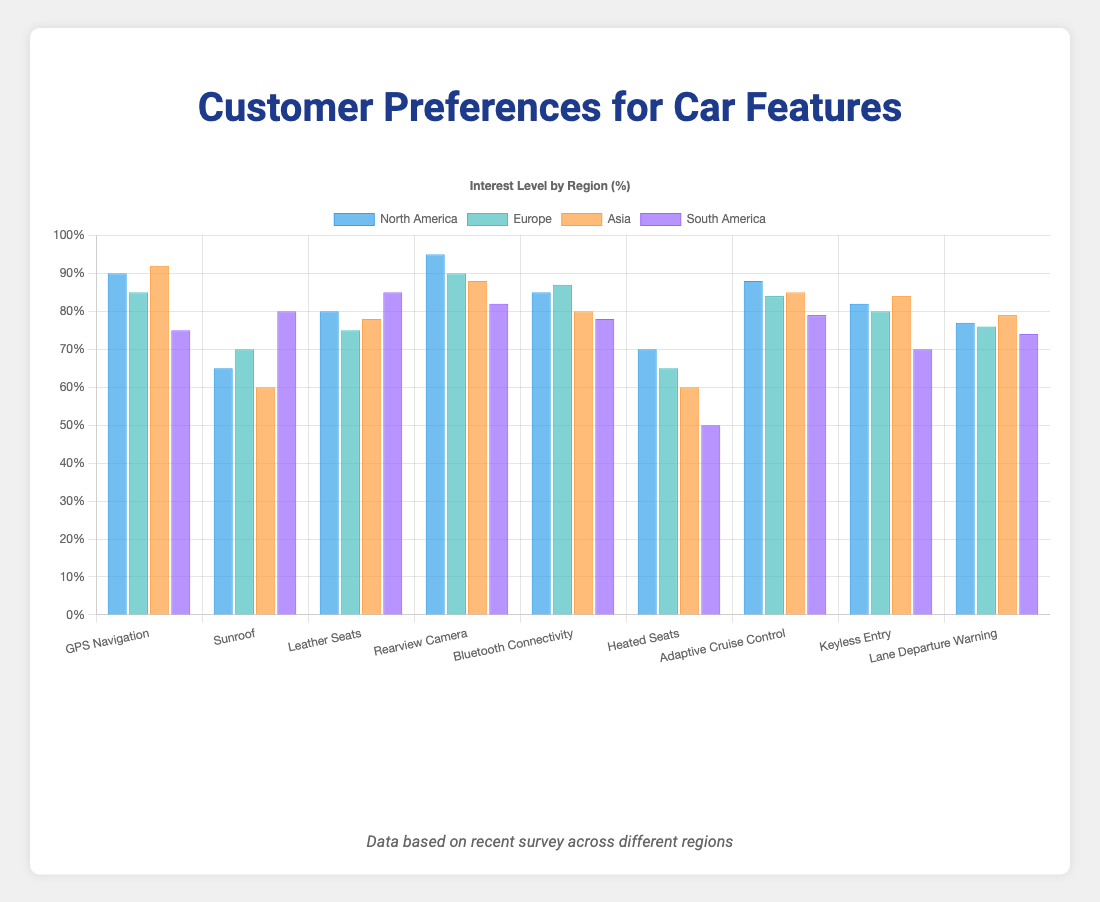What feature has the highest interest level in North America? Look at the bar heights in the "North America" dataset; the tallest bar represents the feature with the highest interest level. "Rearview Camera" with 95% is the highest.
Answer: Rearview Camera Which region shows the least interest in Heated Seats? Compare the bar heights for "Heated Seats" across all regions. The shortest bar for Heated Seats is in South America at 50%.
Answer: South America What's the average interest level in Bluetooth Connectivity across all regions? Sum the interest levels for Bluetooth Connectivity in each region (85 + 87 + 80 + 78) and then divide by the number of regions (4). The calculation is (330 / 4) = 82.5%.
Answer: 82.5% Which feature has almost the same interest level in Europe and Asia? Look for features where the bar heights for Europe and Asia are close to each other. "Adaptive Cruise Control" has 84% for Europe and 85% for Asia.
Answer: Adaptive Cruise Control How does the interest level in Keyless Entry in North America compare to South America? Compare the bar heights for "Keyless Entry" in the North America and South America datasets. North America has 82% and South America has 70%; North America's interest is higher.
Answer: North America has a higher interest Which two regions have the most significant difference in interest levels for Sunroof? Compare the bar heights for "Sunroof" across all regions. The most significant difference is between Asia (60%) and South America (80%), which is a 20% difference.
Answer: Asia and South America Is the interest level for GPS Navigation higher in Europe or North America? Compare the bar heights for "GPS Navigation" in Europe and North America. North America is 90%, and Europe is 85%, so it's higher in North America.
Answer: North America What is the combined interest level for Rearview Camera and Bluetooth Connectivity in Asia? Sum the interest levels for Rearview Camera (88%) and Bluetooth Connectivity (80%) in Asia. The calculation is (88 + 80) = 168%.
Answer: 168% Which feature shows an increasing trend in interest levels from North America to Asia? Look for a feature where the bar heights progressively increase as you move from North America to Europe to Asia. "GPS Navigation" increases from North America (90%) to Europe (85%) to Asia (92%).
Answer: GPS Navigation What's the median interest level for Lane Departure Warning across all regions? List the interest levels for Lane Departure Warning (77, 76, 79, 74), sort them as (74, 76, 77, 79), and find the middle two values (76 and 77). The median is the average of these values: (76 + 77) / 2 = 76.5%.
Answer: 76.5% 